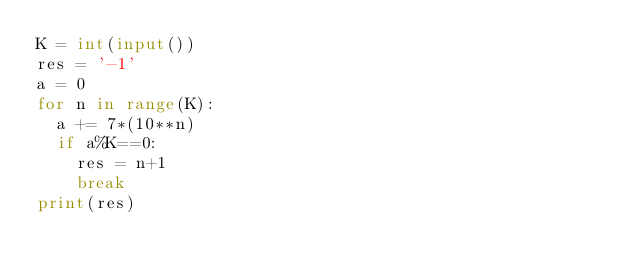<code> <loc_0><loc_0><loc_500><loc_500><_Python_>K = int(input())
res = '-1'
a = 0
for n in range(K):
  a += 7*(10**n)
  if a%K==0:
    res = n+1
    break
print(res)
</code> 